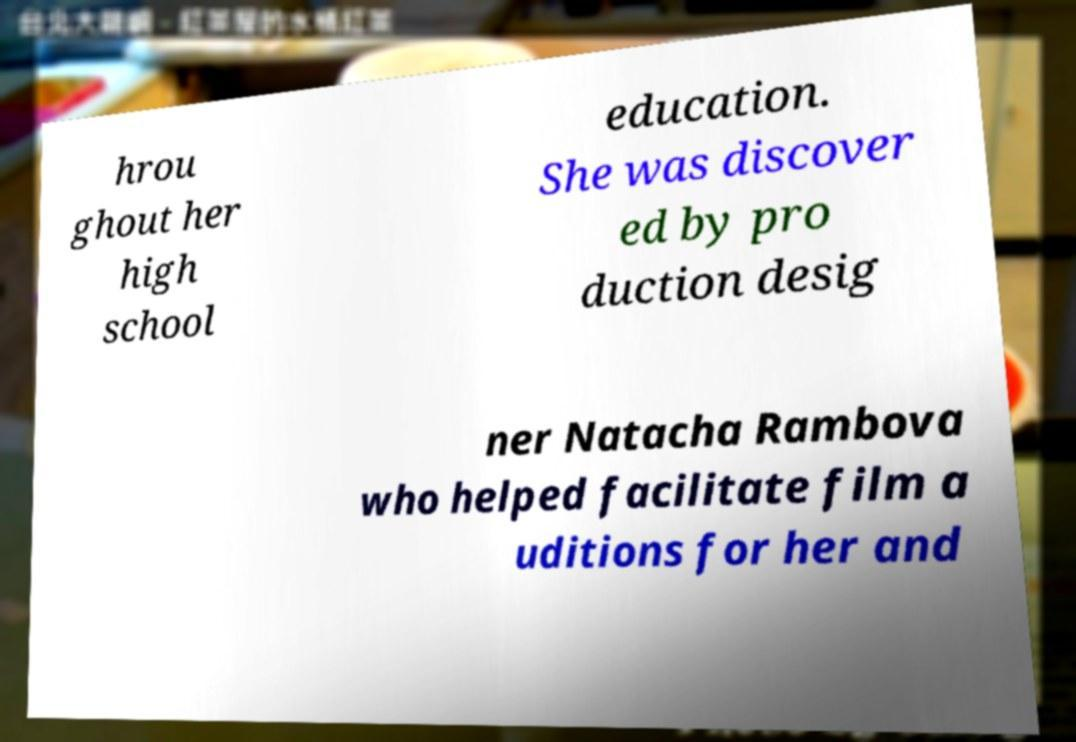Can you read and provide the text displayed in the image?This photo seems to have some interesting text. Can you extract and type it out for me? hrou ghout her high school education. She was discover ed by pro duction desig ner Natacha Rambova who helped facilitate film a uditions for her and 